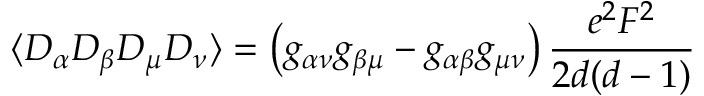Convert formula to latex. <formula><loc_0><loc_0><loc_500><loc_500>\langle D _ { \alpha } D _ { \beta } D _ { \mu } D _ { \nu } \rangle = \left ( g _ { \alpha \nu } g _ { \beta \mu } - g _ { \alpha \beta } g _ { \mu \nu } \right ) \frac { e ^ { 2 } F ^ { 2 } } { 2 d ( d - 1 ) }</formula> 